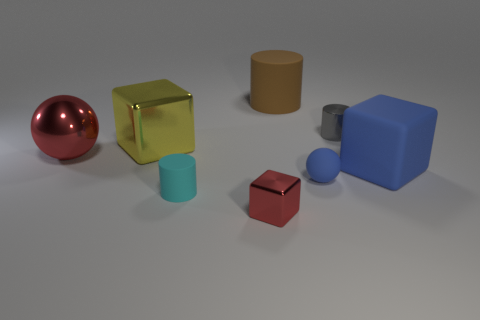What number of cylinders are small gray shiny objects or big objects?
Provide a short and direct response. 2. There is a large cylinder that is the same material as the big blue cube; what is its color?
Ensure brevity in your answer.  Brown. There is a rubber cylinder that is in front of the brown rubber cylinder; does it have the same size as the yellow block?
Your response must be concise. No. Does the big red thing have the same material as the cube to the right of the tiny gray shiny cylinder?
Offer a very short reply. No. The metallic object to the right of the big brown matte cylinder is what color?
Provide a short and direct response. Gray. Is there a big metal cube to the right of the object that is to the right of the gray shiny thing?
Give a very brief answer. No. Do the large block that is to the right of the tiny red metallic cube and the ball on the left side of the small red shiny thing have the same color?
Ensure brevity in your answer.  No. There is a large red ball; what number of red shiny objects are on the right side of it?
Offer a very short reply. 1. How many small spheres have the same color as the matte cube?
Your answer should be compact. 1. Are the big object that is to the right of the blue sphere and the blue sphere made of the same material?
Ensure brevity in your answer.  Yes. 